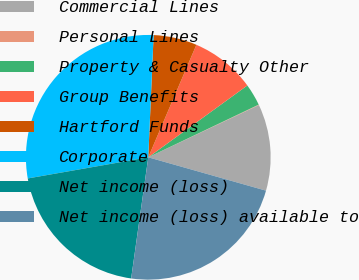<chart> <loc_0><loc_0><loc_500><loc_500><pie_chart><fcel>Commercial Lines<fcel>Personal Lines<fcel>Property & Casualty Other<fcel>Group Benefits<fcel>Hartford Funds<fcel>Corporate<fcel>Net income (loss)<fcel>Net income (loss) available to<nl><fcel>11.42%<fcel>0.06%<fcel>2.9%<fcel>8.58%<fcel>5.74%<fcel>28.46%<fcel>20.0%<fcel>22.84%<nl></chart> 